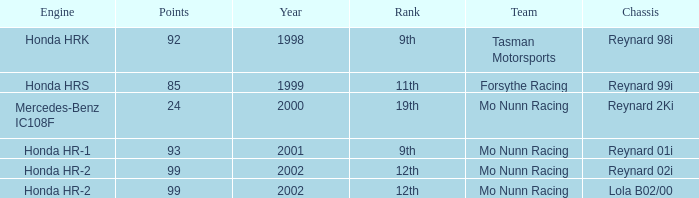What is the rank of the reynard 2ki chassis before 2002? 19th. 